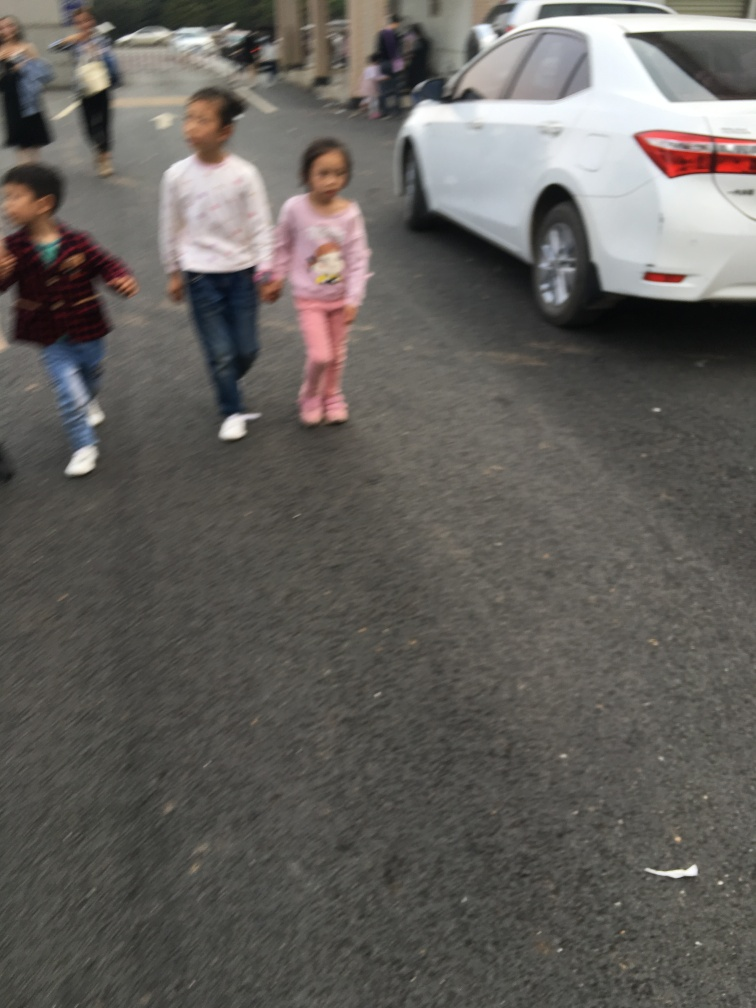Can you tell me more about what's happening in this photo? While the image is blurry, it captures a candid moment with three children walking through what looks like a parking lot. Their expressions and body language could indicate they are either playing or walking to or from an event. The setting suggests a casual, everyday scene, potentially at the end or the start of an outing. 